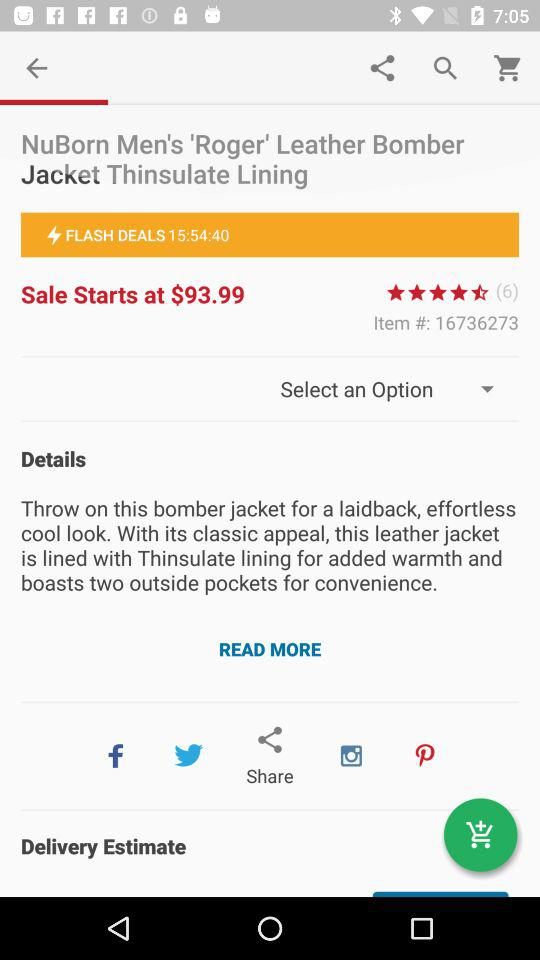Through which application can the content be shared? The content can be shared through "Facebook", "Twitter", "Instagram" and "Pinterest". 